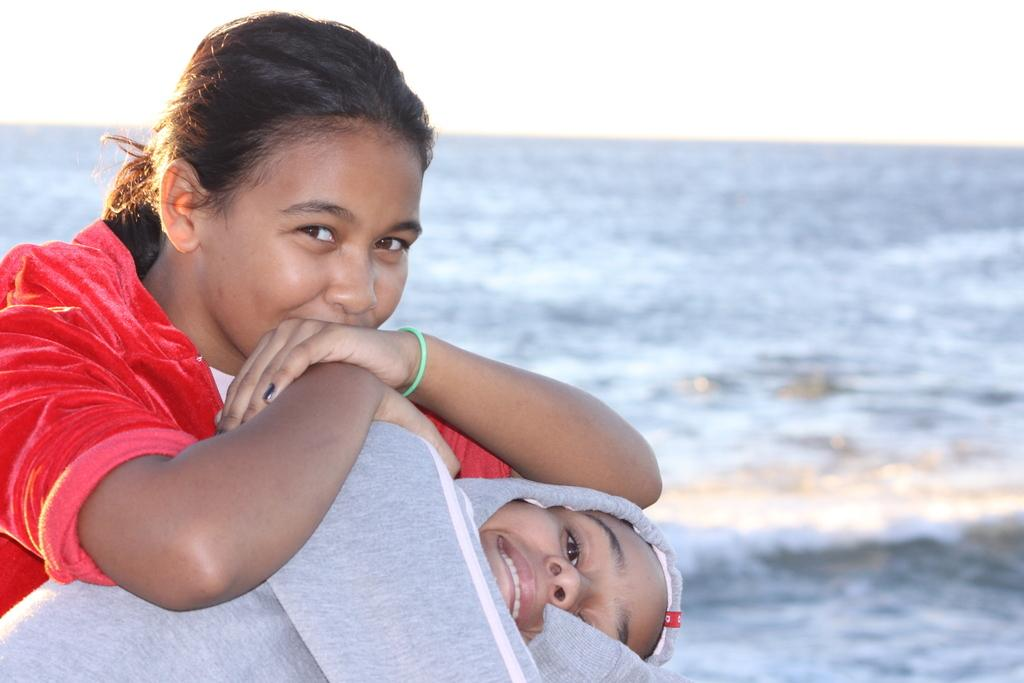How many people are on the left side of the image? There are two people on the left side of the image. What is the facial expression of the two people? The two people are smiling. What are the two people wearing? The two people are wearing different costumes. What can be seen in the background of the image? Sky and water are visible in the background of the image. What type of quince is being used for digestion in the image? There is no quince or reference to digestion present in the image. 